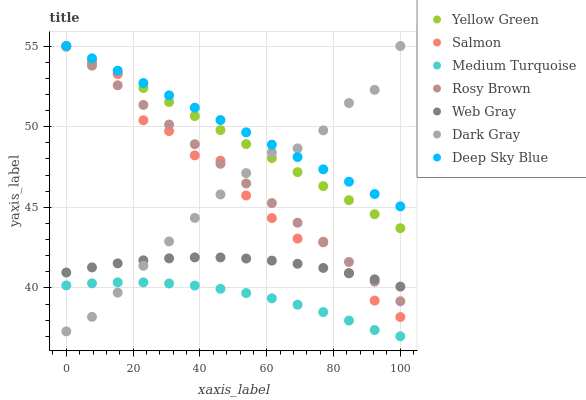Does Medium Turquoise have the minimum area under the curve?
Answer yes or no. Yes. Does Deep Sky Blue have the maximum area under the curve?
Answer yes or no. Yes. Does Yellow Green have the minimum area under the curve?
Answer yes or no. No. Does Yellow Green have the maximum area under the curve?
Answer yes or no. No. Is Rosy Brown the smoothest?
Answer yes or no. Yes. Is Salmon the roughest?
Answer yes or no. Yes. Is Yellow Green the smoothest?
Answer yes or no. No. Is Yellow Green the roughest?
Answer yes or no. No. Does Medium Turquoise have the lowest value?
Answer yes or no. Yes. Does Yellow Green have the lowest value?
Answer yes or no. No. Does Deep Sky Blue have the highest value?
Answer yes or no. Yes. Does Salmon have the highest value?
Answer yes or no. No. Is Salmon less than Deep Sky Blue?
Answer yes or no. Yes. Is Salmon greater than Medium Turquoise?
Answer yes or no. Yes. Does Dark Gray intersect Medium Turquoise?
Answer yes or no. Yes. Is Dark Gray less than Medium Turquoise?
Answer yes or no. No. Is Dark Gray greater than Medium Turquoise?
Answer yes or no. No. Does Salmon intersect Deep Sky Blue?
Answer yes or no. No. 